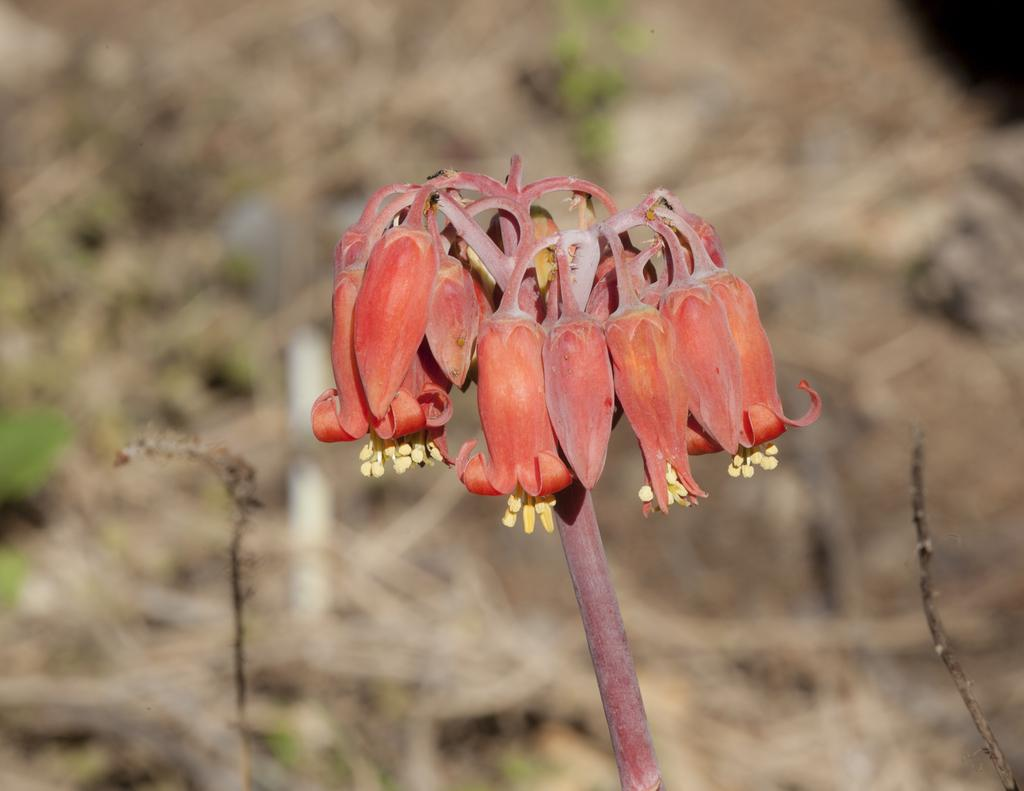What is the main subject of the image? There is a flower in the image. Can you describe the flower's structure? The flower has a stem. What can be observed about the background of the image? The background of the image is blurred. What type of thread is used to hold the cushion in the image? There is no thread or cushion present in the image; it features a flower with a stem and a blurred background. 